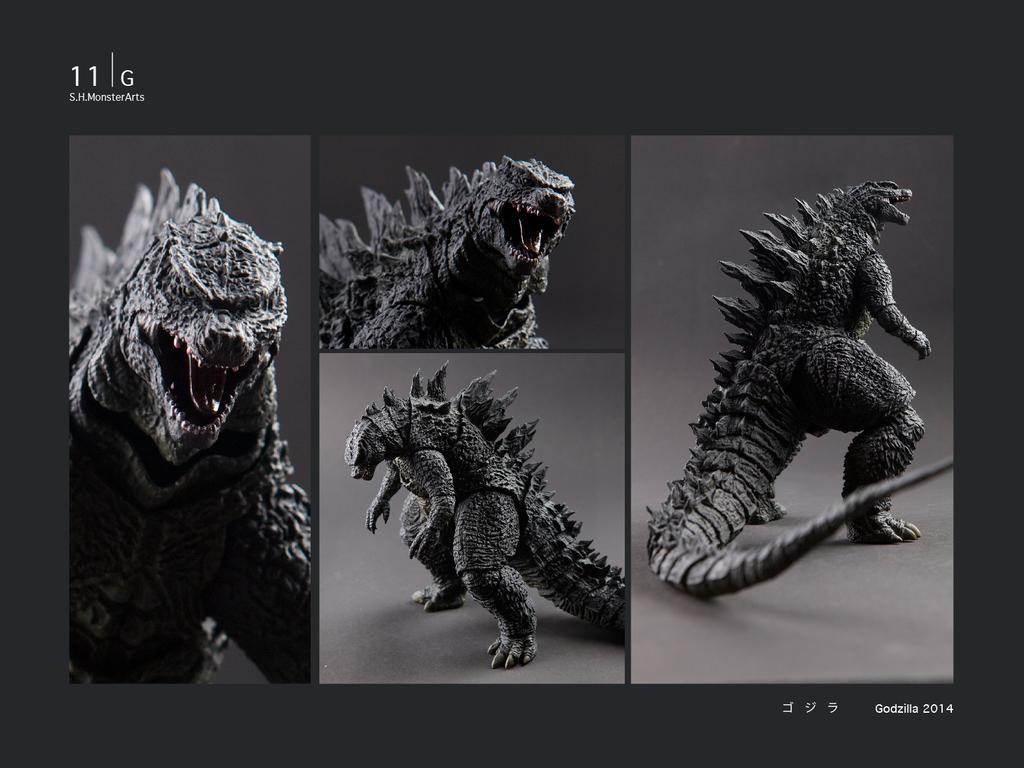Describe this image in one or two sentences. This image is a collage of an animal. At the top and bottom there is text. 